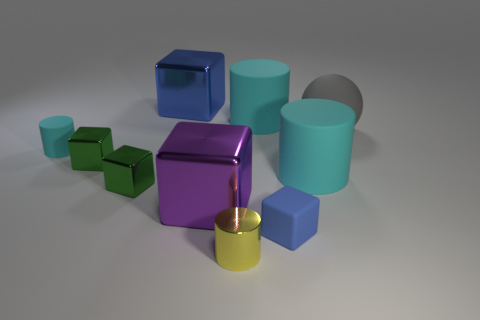Subtract all large shiny cubes. How many cubes are left? 3 Subtract all yellow cylinders. How many cylinders are left? 3 Subtract all balls. How many objects are left? 9 Subtract 1 gray spheres. How many objects are left? 9 Subtract 1 spheres. How many spheres are left? 0 Subtract all gray cubes. Subtract all red spheres. How many cubes are left? 5 Subtract all red cylinders. How many blue cubes are left? 2 Subtract all green metallic blocks. Subtract all big things. How many objects are left? 3 Add 2 large purple cubes. How many large purple cubes are left? 3 Add 1 gray spheres. How many gray spheres exist? 2 